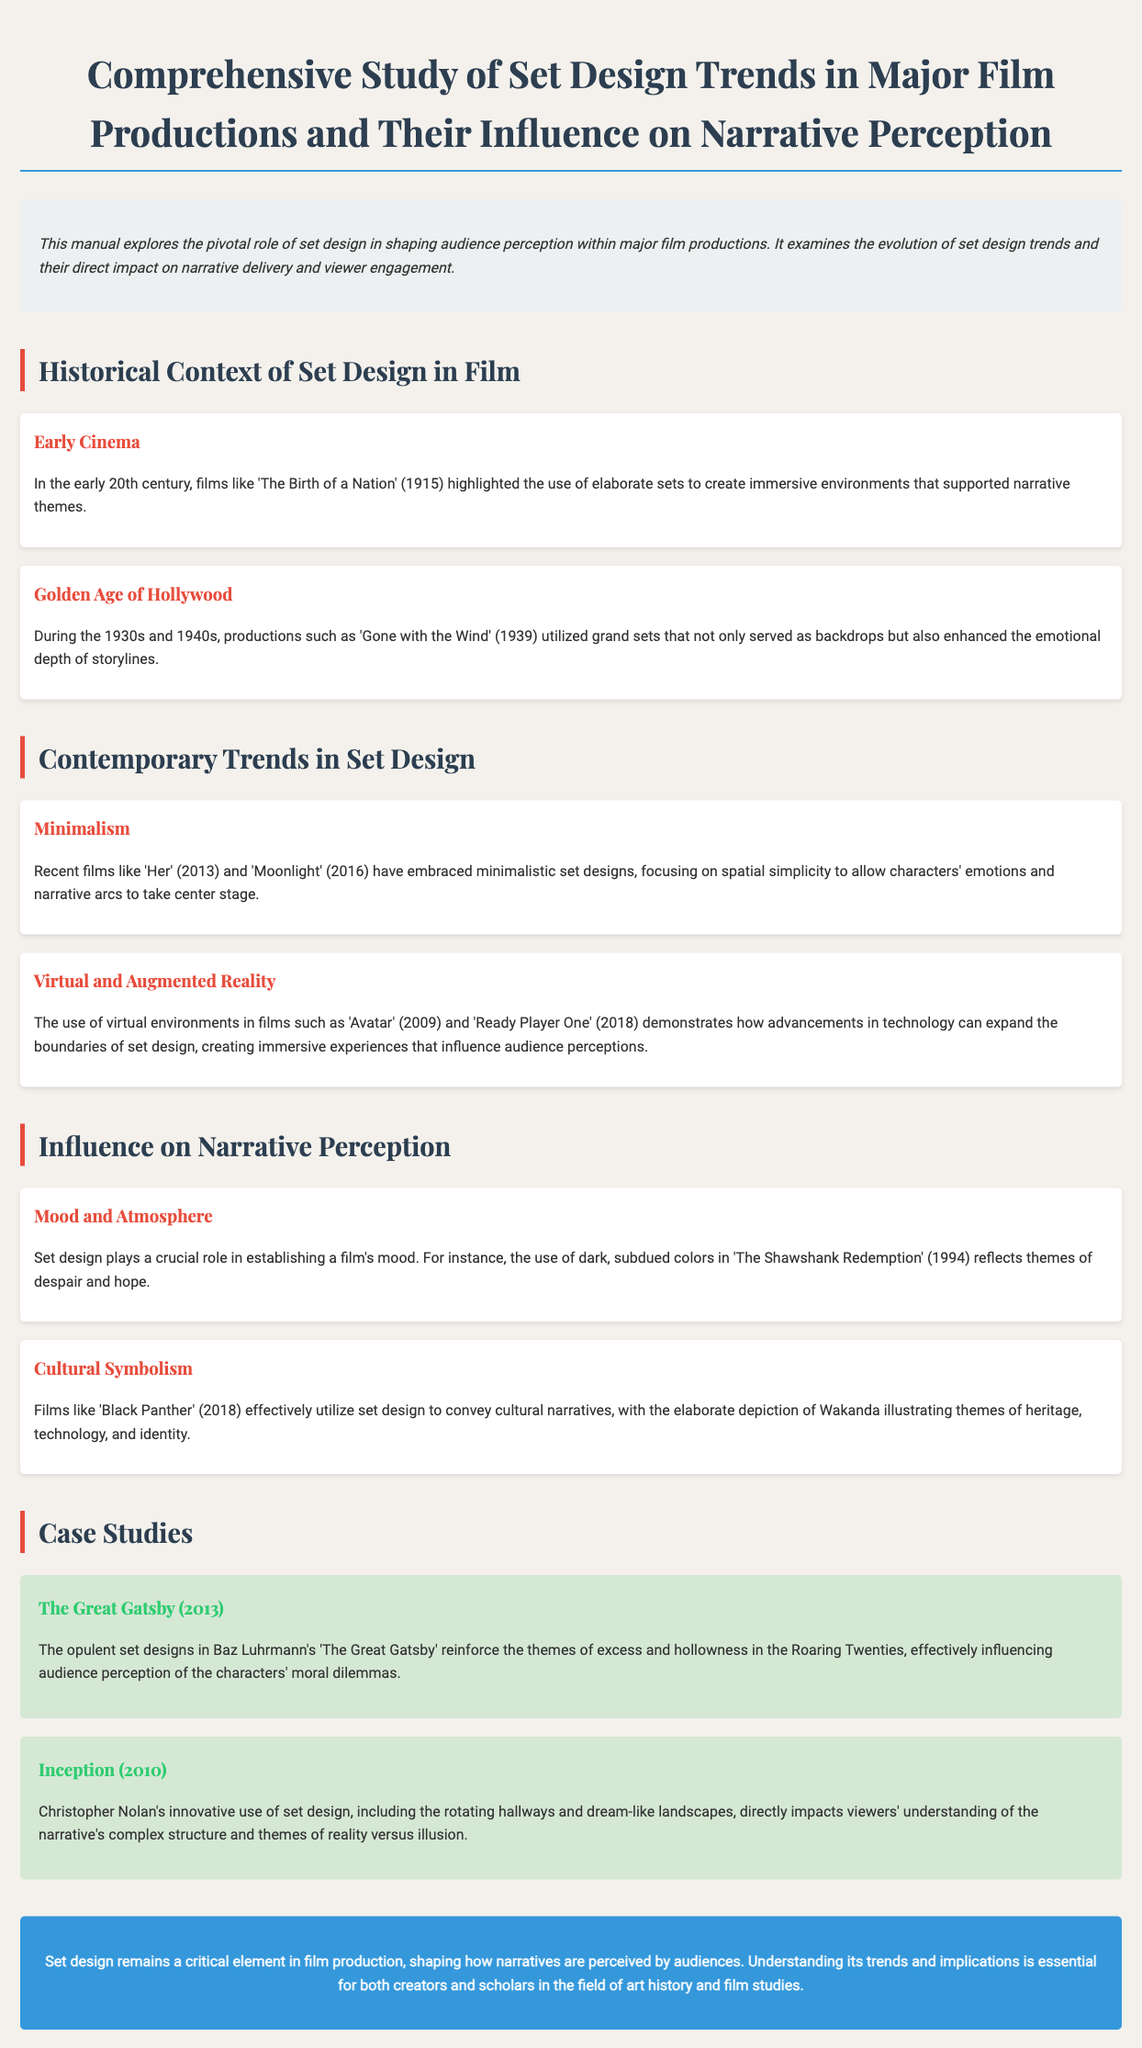what is the title of the manual? The title is explicitly stated at the beginning of the document, describing the focus of the study.
Answer: Comprehensive Study of Set Design Trends in Major Film Productions and Their Influence on Narrative Perception which film is mentioned as an example of early cinema? The document provides an example of early cinema that utilized elaborate sets, specifically named in the text.
Answer: The Birth of a Nation what design trend is highlighted in the section about contemporary trends? The manual lists specific design trends that are relevant to contemporary films, among which one is explicitly mentioned.
Answer: Minimalism what does set design contribute to a film’s mood according to the document? The document explains the role of set design in creating a particular emotional quality, noted in a specific example.
Answer: Mood and Atmosphere which film's set design symbolizes cultural narratives? The manual analyzes the use of set design in films to convey deeper meanings, identifying one film in particular.
Answer: Black Panther how many case studies are presented in the document? The document includes distinct case studies, and the total number is enumerated explicitly.
Answer: Two who directed The Great Gatsby? The director of the film is mentioned within the case study section, and this specific detail is included.
Answer: Baz Luhrmann what year was the film Inception released? The document provides the release year of the mentioned case study film, which can be found in the text.
Answer: 2010 what is the main focus of the introduction section? The introduction outlines the overarching theme of the manual, specifically regarding set design and its impact.
Answer: Set design in shaping audience perception 